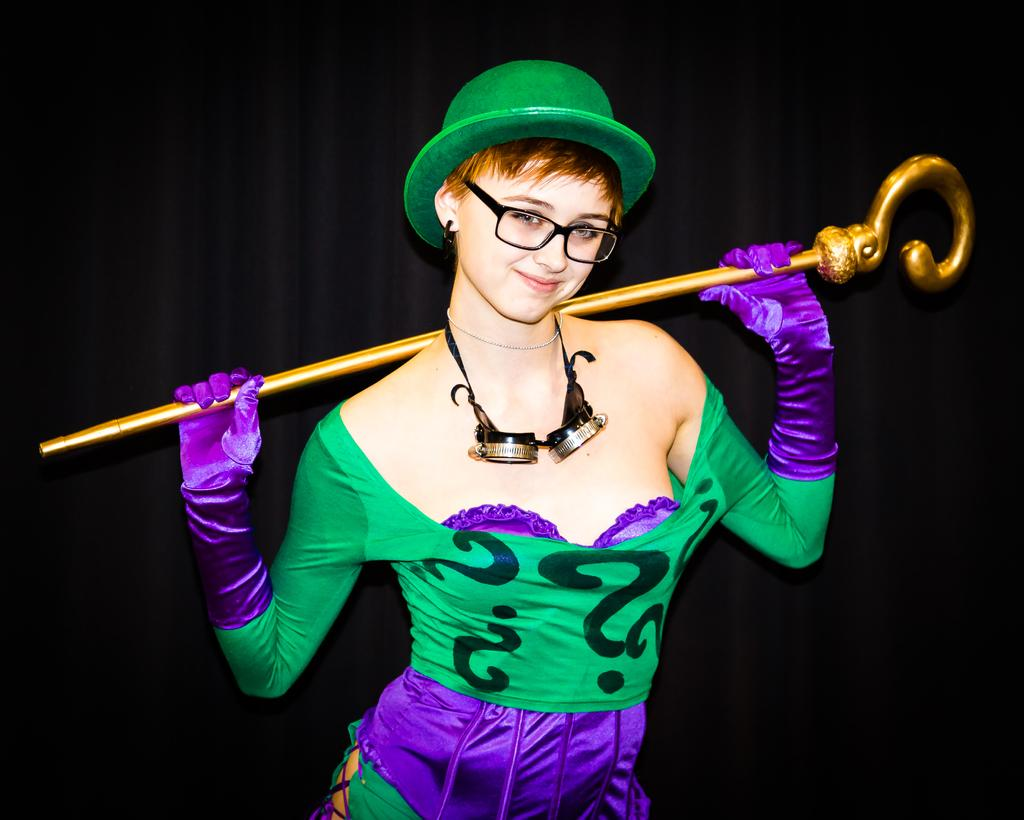Who is the main subject in the image? There is a lady in the image. What is the lady wearing on her head? The lady is wearing a cap. What object is the lady holding in her hand? The lady is holding a stick. What type of snow can be seen falling in the image? There is no snow present in the image; it features a lady wearing a cap and holding a stick. 